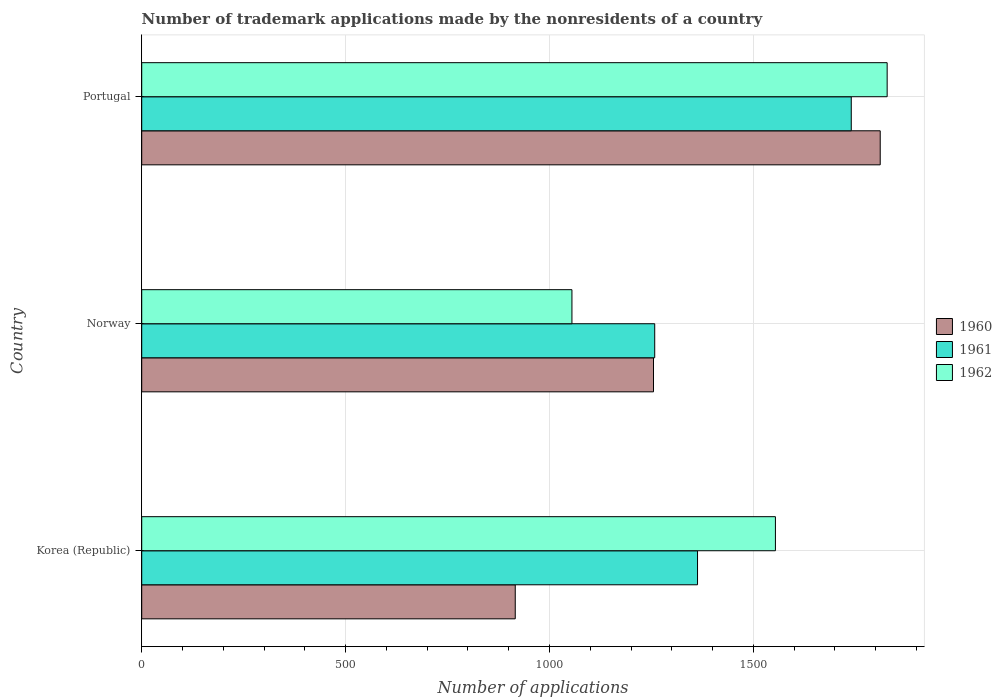How many groups of bars are there?
Provide a succinct answer. 3. Are the number of bars per tick equal to the number of legend labels?
Your response must be concise. Yes. What is the number of trademark applications made by the nonresidents in 1961 in Norway?
Your answer should be very brief. 1258. Across all countries, what is the maximum number of trademark applications made by the nonresidents in 1962?
Provide a succinct answer. 1828. Across all countries, what is the minimum number of trademark applications made by the nonresidents in 1960?
Offer a terse response. 916. In which country was the number of trademark applications made by the nonresidents in 1961 minimum?
Provide a succinct answer. Norway. What is the total number of trademark applications made by the nonresidents in 1961 in the graph?
Your answer should be very brief. 4361. What is the difference between the number of trademark applications made by the nonresidents in 1960 in Norway and that in Portugal?
Offer a terse response. -556. What is the difference between the number of trademark applications made by the nonresidents in 1960 in Korea (Republic) and the number of trademark applications made by the nonresidents in 1962 in Portugal?
Give a very brief answer. -912. What is the average number of trademark applications made by the nonresidents in 1961 per country?
Make the answer very short. 1453.67. What is the difference between the number of trademark applications made by the nonresidents in 1960 and number of trademark applications made by the nonresidents in 1962 in Norway?
Keep it short and to the point. 200. What is the ratio of the number of trademark applications made by the nonresidents in 1962 in Norway to that in Portugal?
Provide a succinct answer. 0.58. Is the difference between the number of trademark applications made by the nonresidents in 1960 in Norway and Portugal greater than the difference between the number of trademark applications made by the nonresidents in 1962 in Norway and Portugal?
Your answer should be very brief. Yes. What is the difference between the highest and the second highest number of trademark applications made by the nonresidents in 1960?
Provide a succinct answer. 556. What is the difference between the highest and the lowest number of trademark applications made by the nonresidents in 1961?
Provide a short and direct response. 482. In how many countries, is the number of trademark applications made by the nonresidents in 1962 greater than the average number of trademark applications made by the nonresidents in 1962 taken over all countries?
Offer a terse response. 2. What does the 2nd bar from the top in Norway represents?
Provide a short and direct response. 1961. How many bars are there?
Offer a very short reply. 9. Are all the bars in the graph horizontal?
Your answer should be very brief. Yes. How many countries are there in the graph?
Make the answer very short. 3. Are the values on the major ticks of X-axis written in scientific E-notation?
Your answer should be very brief. No. Does the graph contain any zero values?
Your answer should be very brief. No. How are the legend labels stacked?
Keep it short and to the point. Vertical. What is the title of the graph?
Ensure brevity in your answer.  Number of trademark applications made by the nonresidents of a country. Does "1962" appear as one of the legend labels in the graph?
Your answer should be compact. Yes. What is the label or title of the X-axis?
Offer a terse response. Number of applications. What is the Number of applications in 1960 in Korea (Republic)?
Provide a short and direct response. 916. What is the Number of applications in 1961 in Korea (Republic)?
Your answer should be compact. 1363. What is the Number of applications in 1962 in Korea (Republic)?
Keep it short and to the point. 1554. What is the Number of applications in 1960 in Norway?
Your answer should be very brief. 1255. What is the Number of applications in 1961 in Norway?
Your response must be concise. 1258. What is the Number of applications of 1962 in Norway?
Your answer should be compact. 1055. What is the Number of applications of 1960 in Portugal?
Offer a very short reply. 1811. What is the Number of applications in 1961 in Portugal?
Provide a short and direct response. 1740. What is the Number of applications in 1962 in Portugal?
Offer a very short reply. 1828. Across all countries, what is the maximum Number of applications of 1960?
Offer a terse response. 1811. Across all countries, what is the maximum Number of applications of 1961?
Offer a very short reply. 1740. Across all countries, what is the maximum Number of applications of 1962?
Provide a short and direct response. 1828. Across all countries, what is the minimum Number of applications in 1960?
Provide a short and direct response. 916. Across all countries, what is the minimum Number of applications of 1961?
Offer a very short reply. 1258. Across all countries, what is the minimum Number of applications in 1962?
Provide a succinct answer. 1055. What is the total Number of applications in 1960 in the graph?
Your answer should be compact. 3982. What is the total Number of applications of 1961 in the graph?
Give a very brief answer. 4361. What is the total Number of applications in 1962 in the graph?
Offer a terse response. 4437. What is the difference between the Number of applications of 1960 in Korea (Republic) and that in Norway?
Your answer should be very brief. -339. What is the difference between the Number of applications in 1961 in Korea (Republic) and that in Norway?
Give a very brief answer. 105. What is the difference between the Number of applications in 1962 in Korea (Republic) and that in Norway?
Provide a short and direct response. 499. What is the difference between the Number of applications of 1960 in Korea (Republic) and that in Portugal?
Give a very brief answer. -895. What is the difference between the Number of applications of 1961 in Korea (Republic) and that in Portugal?
Your response must be concise. -377. What is the difference between the Number of applications in 1962 in Korea (Republic) and that in Portugal?
Provide a succinct answer. -274. What is the difference between the Number of applications in 1960 in Norway and that in Portugal?
Ensure brevity in your answer.  -556. What is the difference between the Number of applications of 1961 in Norway and that in Portugal?
Your answer should be very brief. -482. What is the difference between the Number of applications of 1962 in Norway and that in Portugal?
Your answer should be compact. -773. What is the difference between the Number of applications of 1960 in Korea (Republic) and the Number of applications of 1961 in Norway?
Offer a very short reply. -342. What is the difference between the Number of applications in 1960 in Korea (Republic) and the Number of applications in 1962 in Norway?
Keep it short and to the point. -139. What is the difference between the Number of applications of 1961 in Korea (Republic) and the Number of applications of 1962 in Norway?
Offer a terse response. 308. What is the difference between the Number of applications in 1960 in Korea (Republic) and the Number of applications in 1961 in Portugal?
Provide a succinct answer. -824. What is the difference between the Number of applications of 1960 in Korea (Republic) and the Number of applications of 1962 in Portugal?
Provide a succinct answer. -912. What is the difference between the Number of applications in 1961 in Korea (Republic) and the Number of applications in 1962 in Portugal?
Make the answer very short. -465. What is the difference between the Number of applications of 1960 in Norway and the Number of applications of 1961 in Portugal?
Provide a succinct answer. -485. What is the difference between the Number of applications of 1960 in Norway and the Number of applications of 1962 in Portugal?
Make the answer very short. -573. What is the difference between the Number of applications in 1961 in Norway and the Number of applications in 1962 in Portugal?
Offer a very short reply. -570. What is the average Number of applications of 1960 per country?
Make the answer very short. 1327.33. What is the average Number of applications in 1961 per country?
Give a very brief answer. 1453.67. What is the average Number of applications in 1962 per country?
Ensure brevity in your answer.  1479. What is the difference between the Number of applications of 1960 and Number of applications of 1961 in Korea (Republic)?
Offer a terse response. -447. What is the difference between the Number of applications in 1960 and Number of applications in 1962 in Korea (Republic)?
Offer a terse response. -638. What is the difference between the Number of applications in 1961 and Number of applications in 1962 in Korea (Republic)?
Your response must be concise. -191. What is the difference between the Number of applications of 1961 and Number of applications of 1962 in Norway?
Offer a terse response. 203. What is the difference between the Number of applications of 1960 and Number of applications of 1961 in Portugal?
Provide a succinct answer. 71. What is the difference between the Number of applications of 1961 and Number of applications of 1962 in Portugal?
Provide a succinct answer. -88. What is the ratio of the Number of applications in 1960 in Korea (Republic) to that in Norway?
Your answer should be very brief. 0.73. What is the ratio of the Number of applications in 1961 in Korea (Republic) to that in Norway?
Your response must be concise. 1.08. What is the ratio of the Number of applications in 1962 in Korea (Republic) to that in Norway?
Offer a terse response. 1.47. What is the ratio of the Number of applications in 1960 in Korea (Republic) to that in Portugal?
Provide a succinct answer. 0.51. What is the ratio of the Number of applications of 1961 in Korea (Republic) to that in Portugal?
Provide a succinct answer. 0.78. What is the ratio of the Number of applications in 1962 in Korea (Republic) to that in Portugal?
Keep it short and to the point. 0.85. What is the ratio of the Number of applications in 1960 in Norway to that in Portugal?
Your response must be concise. 0.69. What is the ratio of the Number of applications in 1961 in Norway to that in Portugal?
Keep it short and to the point. 0.72. What is the ratio of the Number of applications of 1962 in Norway to that in Portugal?
Your answer should be very brief. 0.58. What is the difference between the highest and the second highest Number of applications in 1960?
Your answer should be very brief. 556. What is the difference between the highest and the second highest Number of applications of 1961?
Your answer should be very brief. 377. What is the difference between the highest and the second highest Number of applications of 1962?
Your response must be concise. 274. What is the difference between the highest and the lowest Number of applications of 1960?
Offer a terse response. 895. What is the difference between the highest and the lowest Number of applications of 1961?
Provide a succinct answer. 482. What is the difference between the highest and the lowest Number of applications of 1962?
Provide a short and direct response. 773. 